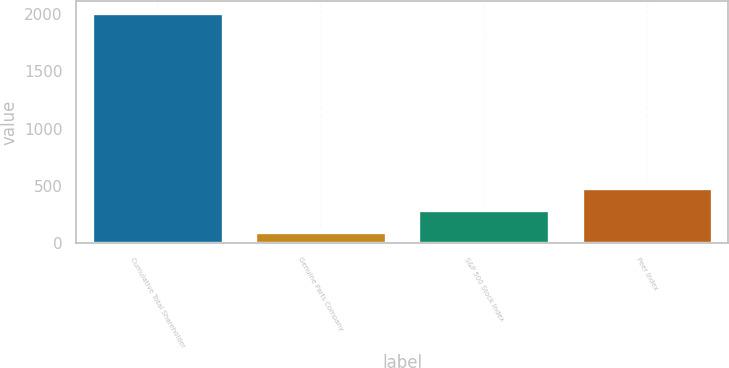Convert chart. <chart><loc_0><loc_0><loc_500><loc_500><bar_chart><fcel>Cumulative Total Shareholder<fcel>Genuine Parts Company<fcel>S&P 500 Stock Index<fcel>Peer Index<nl><fcel>2013<fcel>100<fcel>291.3<fcel>482.6<nl></chart> 